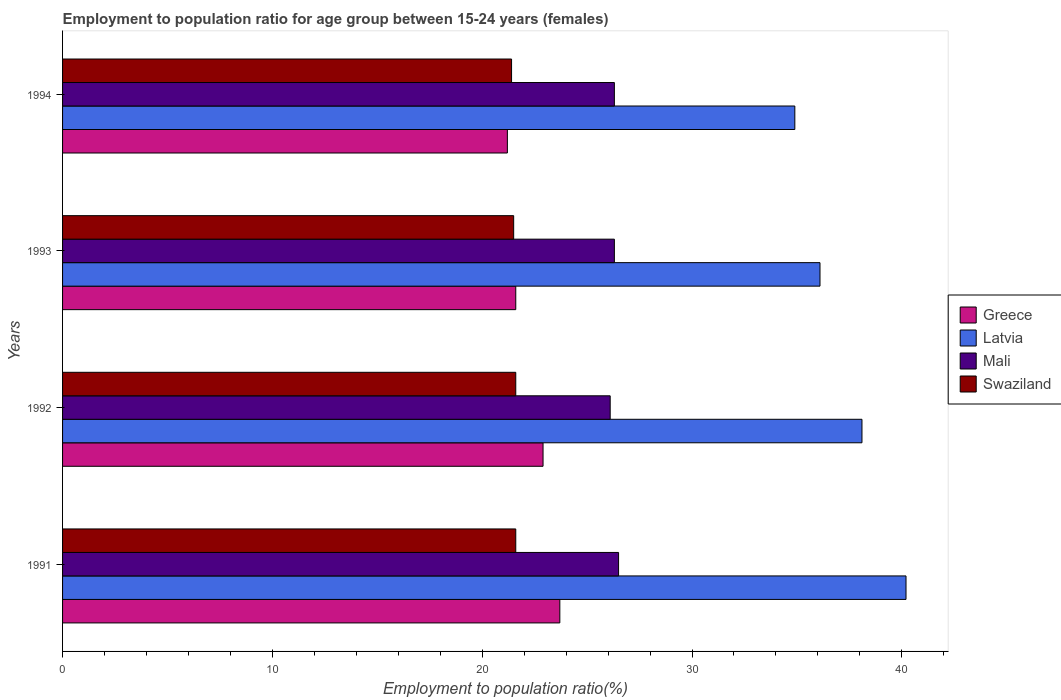How many different coloured bars are there?
Offer a terse response. 4. Are the number of bars per tick equal to the number of legend labels?
Provide a succinct answer. Yes. Are the number of bars on each tick of the Y-axis equal?
Offer a very short reply. Yes. How many bars are there on the 3rd tick from the top?
Give a very brief answer. 4. How many bars are there on the 2nd tick from the bottom?
Provide a succinct answer. 4. What is the label of the 4th group of bars from the top?
Ensure brevity in your answer.  1991. Across all years, what is the maximum employment to population ratio in Swaziland?
Provide a succinct answer. 21.6. Across all years, what is the minimum employment to population ratio in Mali?
Offer a very short reply. 26.1. In which year was the employment to population ratio in Mali maximum?
Keep it short and to the point. 1991. What is the total employment to population ratio in Mali in the graph?
Your response must be concise. 105.2. What is the difference between the employment to population ratio in Mali in 1991 and that in 1992?
Make the answer very short. 0.4. What is the difference between the employment to population ratio in Swaziland in 1993 and the employment to population ratio in Mali in 1992?
Your answer should be very brief. -4.6. What is the average employment to population ratio in Mali per year?
Your response must be concise. 26.3. In the year 1993, what is the difference between the employment to population ratio in Latvia and employment to population ratio in Swaziland?
Make the answer very short. 14.6. What is the ratio of the employment to population ratio in Swaziland in 1991 to that in 1993?
Offer a very short reply. 1. Is the employment to population ratio in Latvia in 1992 less than that in 1994?
Ensure brevity in your answer.  No. Is the difference between the employment to population ratio in Latvia in 1993 and 1994 greater than the difference between the employment to population ratio in Swaziland in 1993 and 1994?
Make the answer very short. Yes. What is the difference between the highest and the second highest employment to population ratio in Greece?
Ensure brevity in your answer.  0.8. What is the difference between the highest and the lowest employment to population ratio in Latvia?
Keep it short and to the point. 5.3. Is the sum of the employment to population ratio in Latvia in 1992 and 1993 greater than the maximum employment to population ratio in Swaziland across all years?
Keep it short and to the point. Yes. Is it the case that in every year, the sum of the employment to population ratio in Latvia and employment to population ratio in Greece is greater than the sum of employment to population ratio in Swaziland and employment to population ratio in Mali?
Ensure brevity in your answer.  Yes. What does the 1st bar from the top in 1993 represents?
Make the answer very short. Swaziland. What does the 4th bar from the bottom in 1994 represents?
Ensure brevity in your answer.  Swaziland. Are all the bars in the graph horizontal?
Make the answer very short. Yes. How many years are there in the graph?
Offer a very short reply. 4. Does the graph contain grids?
Ensure brevity in your answer.  No. Where does the legend appear in the graph?
Provide a succinct answer. Center right. How are the legend labels stacked?
Offer a terse response. Vertical. What is the title of the graph?
Provide a succinct answer. Employment to population ratio for age group between 15-24 years (females). What is the label or title of the Y-axis?
Ensure brevity in your answer.  Years. What is the Employment to population ratio(%) in Greece in 1991?
Offer a terse response. 23.7. What is the Employment to population ratio(%) in Latvia in 1991?
Ensure brevity in your answer.  40.2. What is the Employment to population ratio(%) in Swaziland in 1991?
Your answer should be compact. 21.6. What is the Employment to population ratio(%) in Greece in 1992?
Give a very brief answer. 22.9. What is the Employment to population ratio(%) of Latvia in 1992?
Your response must be concise. 38.1. What is the Employment to population ratio(%) in Mali in 1992?
Your answer should be compact. 26.1. What is the Employment to population ratio(%) of Swaziland in 1992?
Your answer should be compact. 21.6. What is the Employment to population ratio(%) in Greece in 1993?
Provide a succinct answer. 21.6. What is the Employment to population ratio(%) of Latvia in 1993?
Your answer should be compact. 36.1. What is the Employment to population ratio(%) in Mali in 1993?
Your answer should be compact. 26.3. What is the Employment to population ratio(%) of Swaziland in 1993?
Your answer should be very brief. 21.5. What is the Employment to population ratio(%) of Greece in 1994?
Your response must be concise. 21.2. What is the Employment to population ratio(%) in Latvia in 1994?
Your response must be concise. 34.9. What is the Employment to population ratio(%) of Mali in 1994?
Give a very brief answer. 26.3. What is the Employment to population ratio(%) in Swaziland in 1994?
Ensure brevity in your answer.  21.4. Across all years, what is the maximum Employment to population ratio(%) of Greece?
Keep it short and to the point. 23.7. Across all years, what is the maximum Employment to population ratio(%) in Latvia?
Your answer should be very brief. 40.2. Across all years, what is the maximum Employment to population ratio(%) of Swaziland?
Provide a short and direct response. 21.6. Across all years, what is the minimum Employment to population ratio(%) of Greece?
Offer a very short reply. 21.2. Across all years, what is the minimum Employment to population ratio(%) in Latvia?
Your response must be concise. 34.9. Across all years, what is the minimum Employment to population ratio(%) of Mali?
Make the answer very short. 26.1. Across all years, what is the minimum Employment to population ratio(%) of Swaziland?
Provide a short and direct response. 21.4. What is the total Employment to population ratio(%) in Greece in the graph?
Provide a short and direct response. 89.4. What is the total Employment to population ratio(%) in Latvia in the graph?
Offer a terse response. 149.3. What is the total Employment to population ratio(%) in Mali in the graph?
Your answer should be compact. 105.2. What is the total Employment to population ratio(%) of Swaziland in the graph?
Your response must be concise. 86.1. What is the difference between the Employment to population ratio(%) of Mali in 1991 and that in 1992?
Make the answer very short. 0.4. What is the difference between the Employment to population ratio(%) of Greece in 1991 and that in 1993?
Provide a short and direct response. 2.1. What is the difference between the Employment to population ratio(%) of Mali in 1991 and that in 1993?
Make the answer very short. 0.2. What is the difference between the Employment to population ratio(%) of Swaziland in 1991 and that in 1993?
Your answer should be compact. 0.1. What is the difference between the Employment to population ratio(%) in Greece in 1991 and that in 1994?
Provide a short and direct response. 2.5. What is the difference between the Employment to population ratio(%) of Latvia in 1992 and that in 1994?
Offer a very short reply. 3.2. What is the difference between the Employment to population ratio(%) of Swaziland in 1992 and that in 1994?
Provide a short and direct response. 0.2. What is the difference between the Employment to population ratio(%) of Mali in 1993 and that in 1994?
Give a very brief answer. 0. What is the difference between the Employment to population ratio(%) of Greece in 1991 and the Employment to population ratio(%) of Latvia in 1992?
Make the answer very short. -14.4. What is the difference between the Employment to population ratio(%) of Greece in 1991 and the Employment to population ratio(%) of Mali in 1992?
Offer a terse response. -2.4. What is the difference between the Employment to population ratio(%) in Greece in 1991 and the Employment to population ratio(%) in Swaziland in 1992?
Your answer should be compact. 2.1. What is the difference between the Employment to population ratio(%) of Latvia in 1991 and the Employment to population ratio(%) of Swaziland in 1992?
Offer a very short reply. 18.6. What is the difference between the Employment to population ratio(%) in Mali in 1991 and the Employment to population ratio(%) in Swaziland in 1992?
Your response must be concise. 4.9. What is the difference between the Employment to population ratio(%) of Greece in 1991 and the Employment to population ratio(%) of Mali in 1993?
Your response must be concise. -2.6. What is the difference between the Employment to population ratio(%) of Mali in 1991 and the Employment to population ratio(%) of Swaziland in 1993?
Give a very brief answer. 5. What is the difference between the Employment to population ratio(%) of Greece in 1991 and the Employment to population ratio(%) of Swaziland in 1994?
Provide a short and direct response. 2.3. What is the difference between the Employment to population ratio(%) in Latvia in 1991 and the Employment to population ratio(%) in Mali in 1994?
Keep it short and to the point. 13.9. What is the difference between the Employment to population ratio(%) of Latvia in 1991 and the Employment to population ratio(%) of Swaziland in 1994?
Give a very brief answer. 18.8. What is the difference between the Employment to population ratio(%) in Latvia in 1992 and the Employment to population ratio(%) in Mali in 1993?
Keep it short and to the point. 11.8. What is the difference between the Employment to population ratio(%) in Mali in 1992 and the Employment to population ratio(%) in Swaziland in 1993?
Offer a terse response. 4.6. What is the difference between the Employment to population ratio(%) in Greece in 1992 and the Employment to population ratio(%) in Latvia in 1994?
Provide a short and direct response. -12. What is the difference between the Employment to population ratio(%) of Greece in 1992 and the Employment to population ratio(%) of Swaziland in 1994?
Your response must be concise. 1.5. What is the difference between the Employment to population ratio(%) of Latvia in 1992 and the Employment to population ratio(%) of Mali in 1994?
Provide a succinct answer. 11.8. What is the difference between the Employment to population ratio(%) of Mali in 1992 and the Employment to population ratio(%) of Swaziland in 1994?
Give a very brief answer. 4.7. What is the difference between the Employment to population ratio(%) of Greece in 1993 and the Employment to population ratio(%) of Swaziland in 1994?
Your response must be concise. 0.2. What is the difference between the Employment to population ratio(%) of Mali in 1993 and the Employment to population ratio(%) of Swaziland in 1994?
Keep it short and to the point. 4.9. What is the average Employment to population ratio(%) of Greece per year?
Your answer should be compact. 22.35. What is the average Employment to population ratio(%) in Latvia per year?
Your answer should be compact. 37.33. What is the average Employment to population ratio(%) of Mali per year?
Provide a short and direct response. 26.3. What is the average Employment to population ratio(%) in Swaziland per year?
Ensure brevity in your answer.  21.52. In the year 1991, what is the difference between the Employment to population ratio(%) of Greece and Employment to population ratio(%) of Latvia?
Offer a terse response. -16.5. In the year 1991, what is the difference between the Employment to population ratio(%) in Greece and Employment to population ratio(%) in Mali?
Offer a very short reply. -2.8. In the year 1991, what is the difference between the Employment to population ratio(%) of Latvia and Employment to population ratio(%) of Mali?
Ensure brevity in your answer.  13.7. In the year 1991, what is the difference between the Employment to population ratio(%) in Latvia and Employment to population ratio(%) in Swaziland?
Ensure brevity in your answer.  18.6. In the year 1991, what is the difference between the Employment to population ratio(%) of Mali and Employment to population ratio(%) of Swaziland?
Make the answer very short. 4.9. In the year 1992, what is the difference between the Employment to population ratio(%) of Greece and Employment to population ratio(%) of Latvia?
Ensure brevity in your answer.  -15.2. In the year 1992, what is the difference between the Employment to population ratio(%) in Greece and Employment to population ratio(%) in Mali?
Your answer should be compact. -3.2. In the year 1992, what is the difference between the Employment to population ratio(%) in Greece and Employment to population ratio(%) in Swaziland?
Offer a terse response. 1.3. In the year 1992, what is the difference between the Employment to population ratio(%) of Latvia and Employment to population ratio(%) of Mali?
Make the answer very short. 12. In the year 1992, what is the difference between the Employment to population ratio(%) in Latvia and Employment to population ratio(%) in Swaziland?
Provide a short and direct response. 16.5. In the year 1993, what is the difference between the Employment to population ratio(%) of Latvia and Employment to population ratio(%) of Swaziland?
Offer a terse response. 14.6. In the year 1994, what is the difference between the Employment to population ratio(%) in Greece and Employment to population ratio(%) in Latvia?
Make the answer very short. -13.7. In the year 1994, what is the difference between the Employment to population ratio(%) of Greece and Employment to population ratio(%) of Mali?
Provide a short and direct response. -5.1. In the year 1994, what is the difference between the Employment to population ratio(%) in Latvia and Employment to population ratio(%) in Mali?
Your answer should be compact. 8.6. In the year 1994, what is the difference between the Employment to population ratio(%) of Latvia and Employment to population ratio(%) of Swaziland?
Your response must be concise. 13.5. In the year 1994, what is the difference between the Employment to population ratio(%) in Mali and Employment to population ratio(%) in Swaziland?
Offer a very short reply. 4.9. What is the ratio of the Employment to population ratio(%) of Greece in 1991 to that in 1992?
Give a very brief answer. 1.03. What is the ratio of the Employment to population ratio(%) of Latvia in 1991 to that in 1992?
Keep it short and to the point. 1.06. What is the ratio of the Employment to population ratio(%) in Mali in 1991 to that in 1992?
Give a very brief answer. 1.02. What is the ratio of the Employment to population ratio(%) of Greece in 1991 to that in 1993?
Ensure brevity in your answer.  1.1. What is the ratio of the Employment to population ratio(%) of Latvia in 1991 to that in 1993?
Keep it short and to the point. 1.11. What is the ratio of the Employment to population ratio(%) in Mali in 1991 to that in 1993?
Your answer should be compact. 1.01. What is the ratio of the Employment to population ratio(%) of Greece in 1991 to that in 1994?
Provide a succinct answer. 1.12. What is the ratio of the Employment to population ratio(%) in Latvia in 1991 to that in 1994?
Provide a succinct answer. 1.15. What is the ratio of the Employment to population ratio(%) of Mali in 1991 to that in 1994?
Offer a very short reply. 1.01. What is the ratio of the Employment to population ratio(%) of Swaziland in 1991 to that in 1994?
Ensure brevity in your answer.  1.01. What is the ratio of the Employment to population ratio(%) in Greece in 1992 to that in 1993?
Offer a very short reply. 1.06. What is the ratio of the Employment to population ratio(%) of Latvia in 1992 to that in 1993?
Provide a short and direct response. 1.06. What is the ratio of the Employment to population ratio(%) in Mali in 1992 to that in 1993?
Your answer should be compact. 0.99. What is the ratio of the Employment to population ratio(%) in Greece in 1992 to that in 1994?
Give a very brief answer. 1.08. What is the ratio of the Employment to population ratio(%) in Latvia in 1992 to that in 1994?
Your response must be concise. 1.09. What is the ratio of the Employment to population ratio(%) of Mali in 1992 to that in 1994?
Your answer should be very brief. 0.99. What is the ratio of the Employment to population ratio(%) of Swaziland in 1992 to that in 1994?
Your answer should be very brief. 1.01. What is the ratio of the Employment to population ratio(%) in Greece in 1993 to that in 1994?
Offer a very short reply. 1.02. What is the ratio of the Employment to population ratio(%) of Latvia in 1993 to that in 1994?
Your answer should be compact. 1.03. What is the ratio of the Employment to population ratio(%) of Mali in 1993 to that in 1994?
Your answer should be very brief. 1. What is the ratio of the Employment to population ratio(%) of Swaziland in 1993 to that in 1994?
Your response must be concise. 1. What is the difference between the highest and the second highest Employment to population ratio(%) of Mali?
Give a very brief answer. 0.2. What is the difference between the highest and the second highest Employment to population ratio(%) in Swaziland?
Keep it short and to the point. 0. What is the difference between the highest and the lowest Employment to population ratio(%) of Greece?
Make the answer very short. 2.5. What is the difference between the highest and the lowest Employment to population ratio(%) in Mali?
Your answer should be very brief. 0.4. 